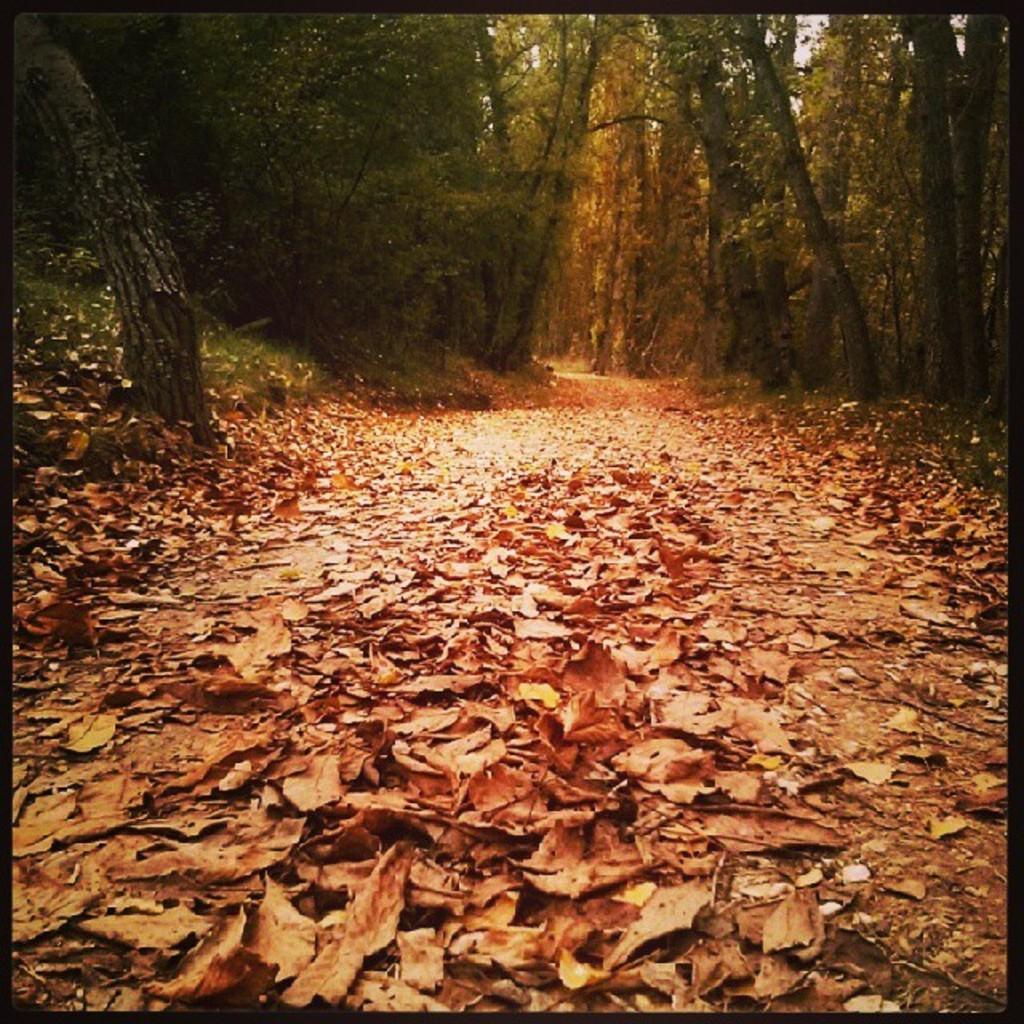In one or two sentences, can you explain what this image depicts? In this image there are few trees, grass and few dried leaves are on the land. In between the trees there is a path. 